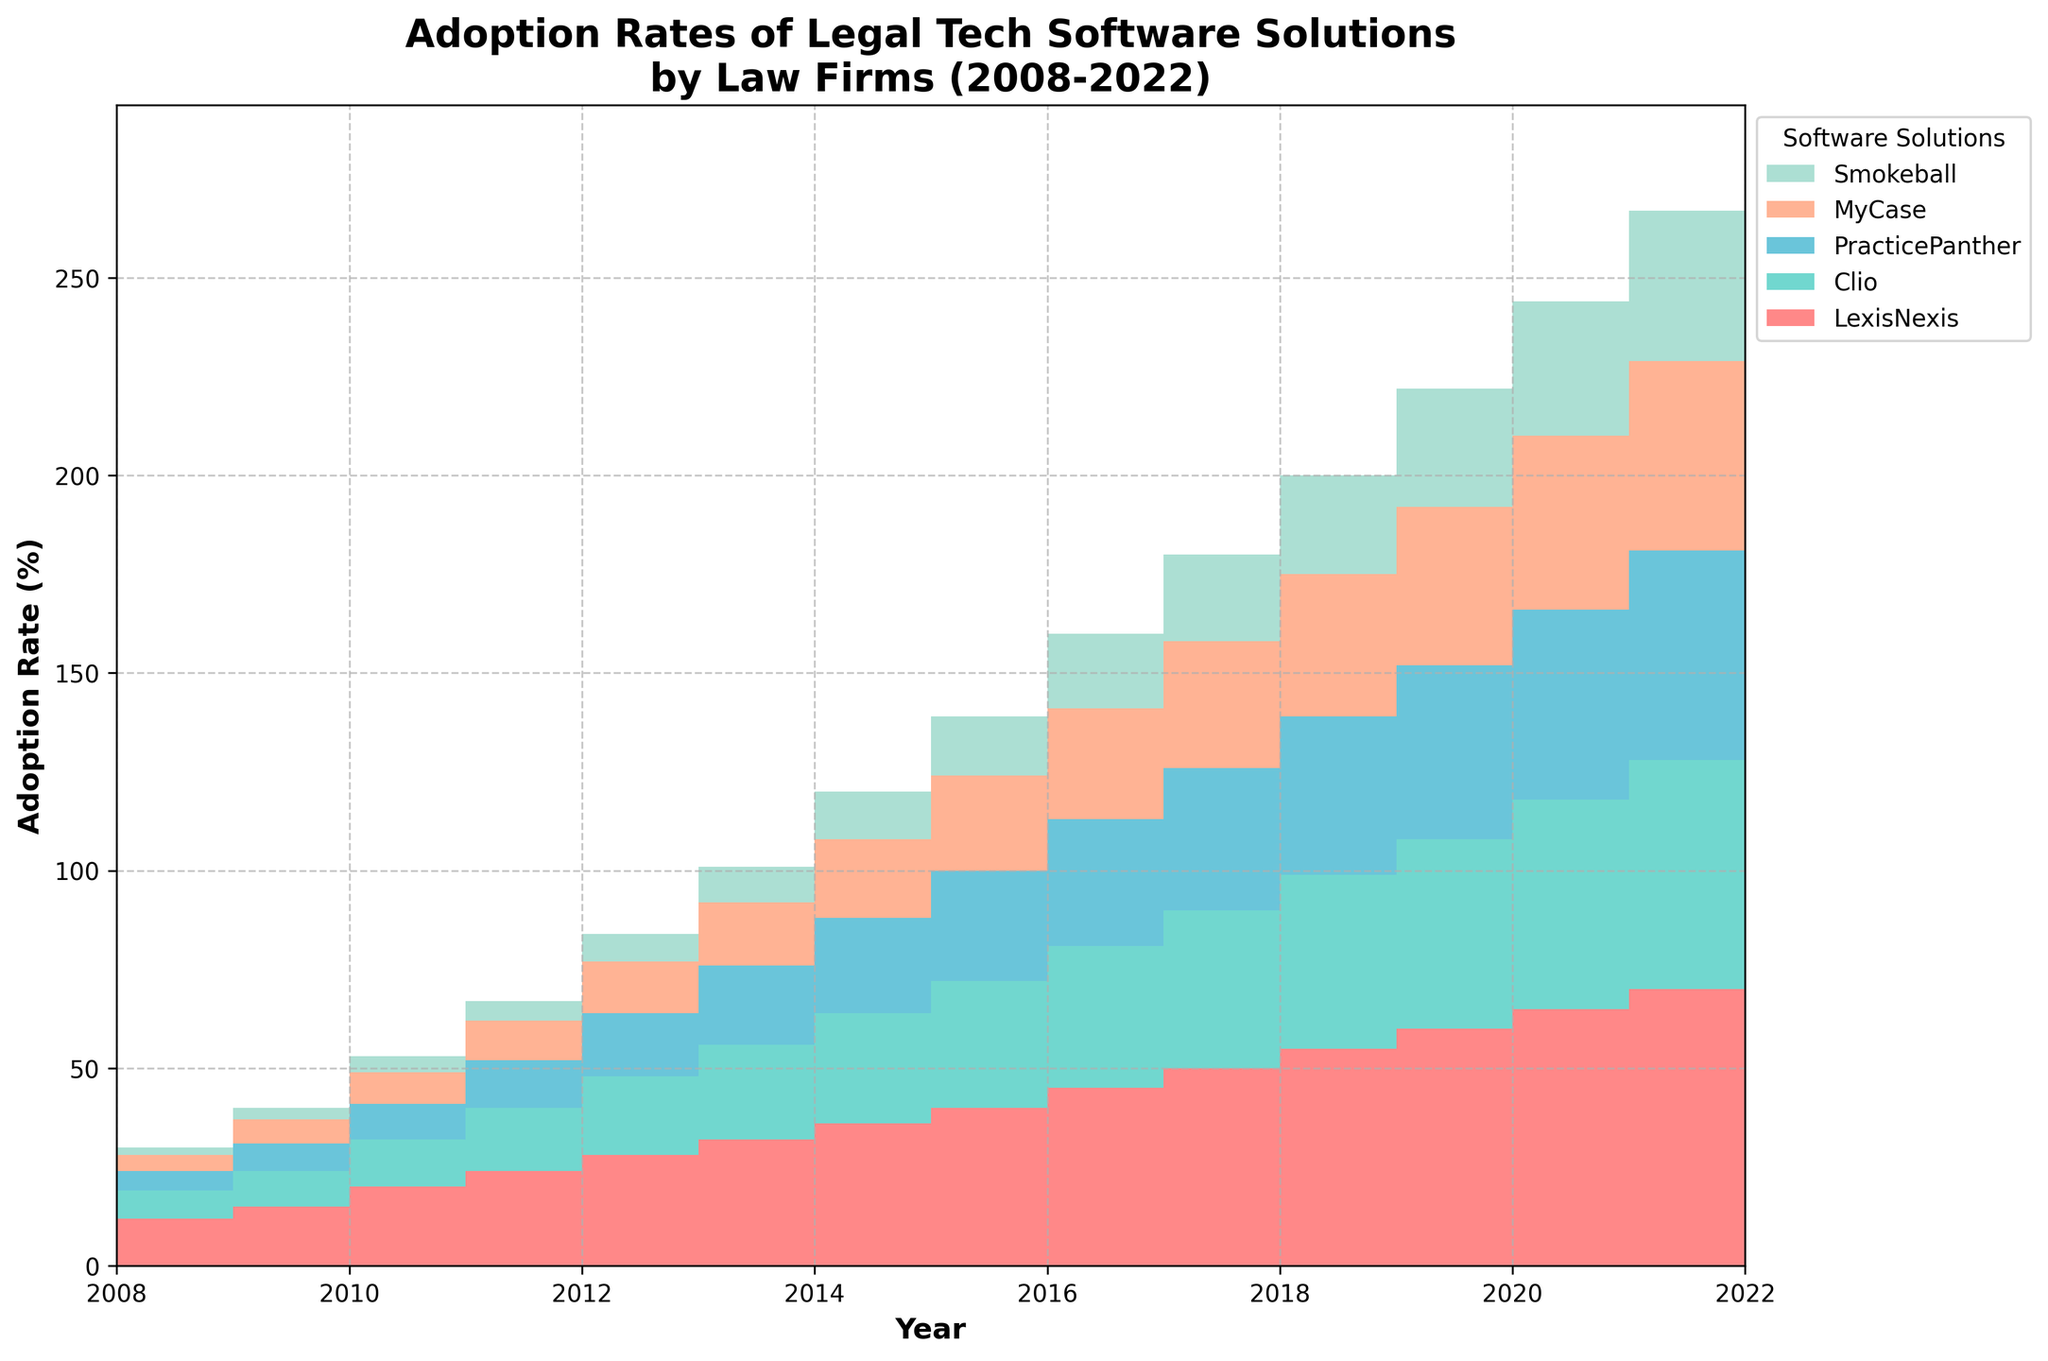What's the title of the chart? The title is located at the top of the chart. It reads "Adoption Rates of Legal Tech Software Solutions by Law Firms (2008-2022)."
Answer: Adoption Rates of Legal Tech Software Solutions by Law Firms (2008-2022) How many software solutions are being compared in the chart? The legend on the right side of the chart lists the software solutions being compared. There are five: LexisNexis, Clio, PracticePanther, MyCase, and Smokeball.
Answer: 5 Between which two years did LexisNexis see the largest increase in adoption rate? By observing the different segments representing LexisNexis on the chart, the largest vertical jump is between 2011 and 2012.
Answer: 2011 and 2012 What is the adoption rate of Clio in 2020? By finding the year 2020 on the x-axis and noting the height of the Clio segment for that year, the adoption rate for Clio is 48%.
Answer: 48% Which software solution had the lowest adoption rate in 2015? By examining the segments representing each software solution in 2015, the lowest is Smokeball at 12%.
Answer: Smokeball Comparing 2018 and 2022, which software solution shows the greatest increase in adoption rate? By subtracting the adoption rate in 2018 from the rate in 2022 for each software solution, we find that LexisNexis shows the greatest increase (70% - 50% = 20%).
Answer: LexisNexis What is the trend of adoption rates for PracticePanther from 2008 to 2022? By following the segments for PracticePanther along the x-axis from 2008 to 2022, the trend shows a consistent increase over the years.
Answer: Consistent increase Which year saw the highest overall adoption rate sum across all software solutions? By adding the adoption rates for all software solutions in each year and comparing, 2022 has the highest sum. For example, 70 (LexisNexis) + 58 (Clio) + 53 (PracticePanther) + 48 (MyCase) + 38 (Smokeball) = 267.
Answer: 2022 How does the adoption rate of Smokeball in 2010 compare to MyCase in the same year? By examining the segments representing Smokeball and MyCase in 2010, Smokeball has an adoption rate of 3%, while MyCase has 6%. Smokeball is lower.
Answer: Lower 